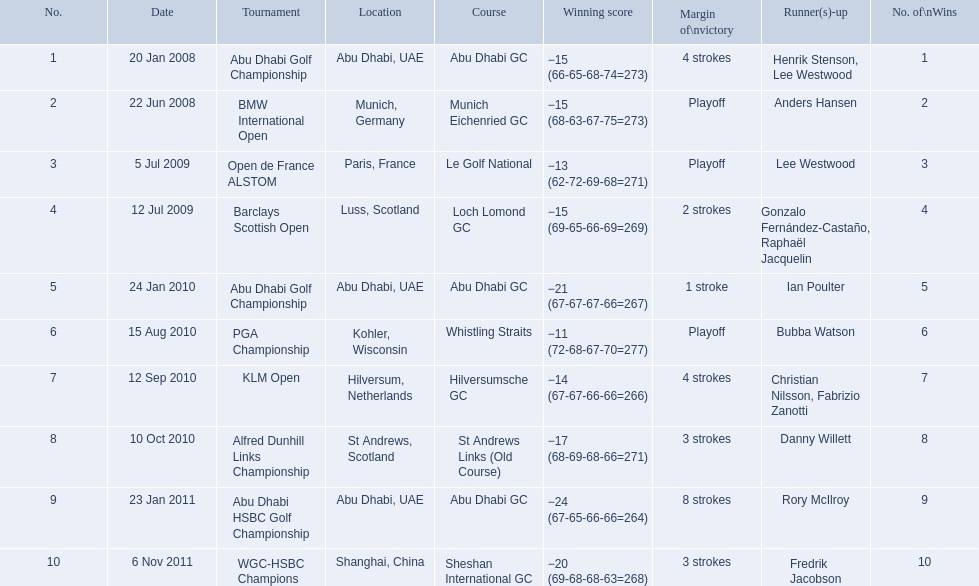What are all of the tournaments? Abu Dhabi Golf Championship, BMW International Open, Open de France ALSTOM, Barclays Scottish Open, Abu Dhabi Golf Championship, PGA Championship, KLM Open, Alfred Dunhill Links Championship, Abu Dhabi HSBC Golf Championship, WGC-HSBC Champions. What was the score during each? −15 (66-65-68-74=273), −15 (68-63-67-75=273), −13 (62-72-69-68=271), −15 (69-65-66-69=269), −21 (67-67-67-66=267), −11 (72-68-67-70=277), −14 (67-67-66-66=266), −17 (68-69-68-66=271), −24 (67-65-66-66=264), −20 (69-68-68-63=268). And who was the runner-up in each? Henrik Stenson, Lee Westwood, Anders Hansen, Lee Westwood, Gonzalo Fernández-Castaño, Raphaël Jacquelin, Ian Poulter, Bubba Watson, Christian Nilsson, Fabrizio Zanotti, Danny Willett, Rory McIlroy, Fredrik Jacobson. What about just during pga games? Bubba Watson. 